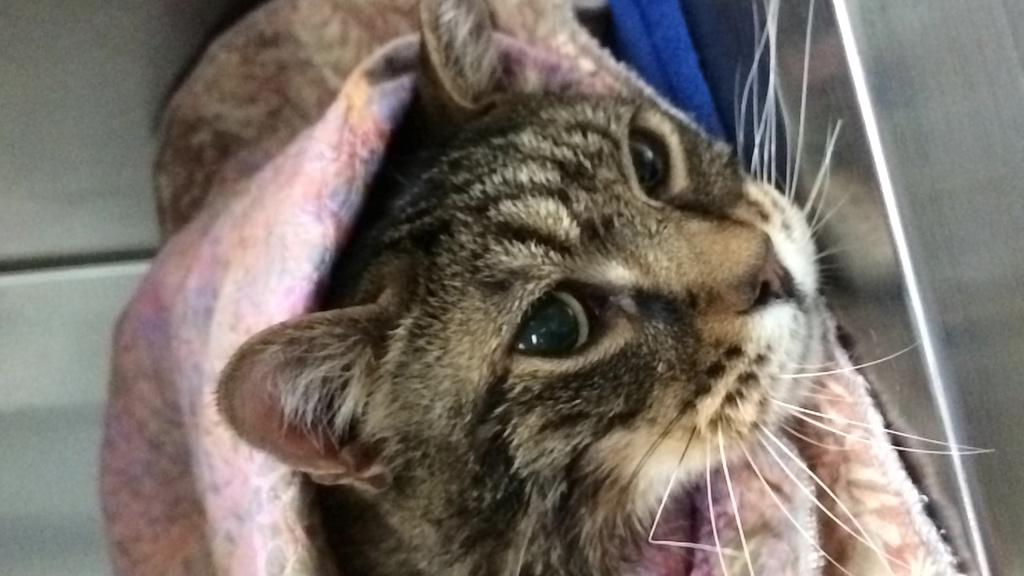What type of animal is in the image? There is a cat in the image. How is the cat positioned in the image? The cat is wrapped around a cloth. What type of land can be seen in the image? There is no land visible in the image, as it features a cat wrapped around a cloth. Can you see a monkey in the image? No, there is no monkey present in the image. 